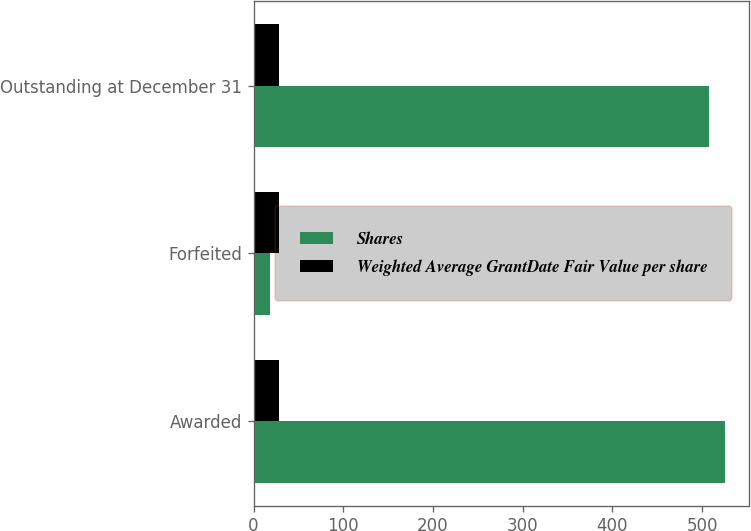Convert chart to OTSL. <chart><loc_0><loc_0><loc_500><loc_500><stacked_bar_chart><ecel><fcel>Awarded<fcel>Forfeited<fcel>Outstanding at December 31<nl><fcel>Shares<fcel>526<fcel>18<fcel>508<nl><fcel>Weighted Average GrantDate Fair Value per share<fcel>28.13<fcel>28.15<fcel>28.13<nl></chart> 